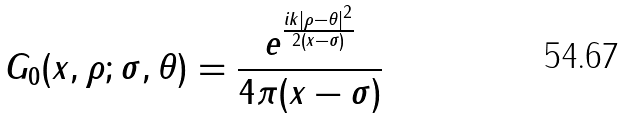<formula> <loc_0><loc_0><loc_500><loc_500>G _ { 0 } ( x , \rho ; \sigma , \theta ) = \frac { e ^ { \frac { i k | \rho - \theta | ^ { 2 } } { 2 ( x - \sigma ) } } } { 4 \pi ( x - \sigma ) }</formula> 